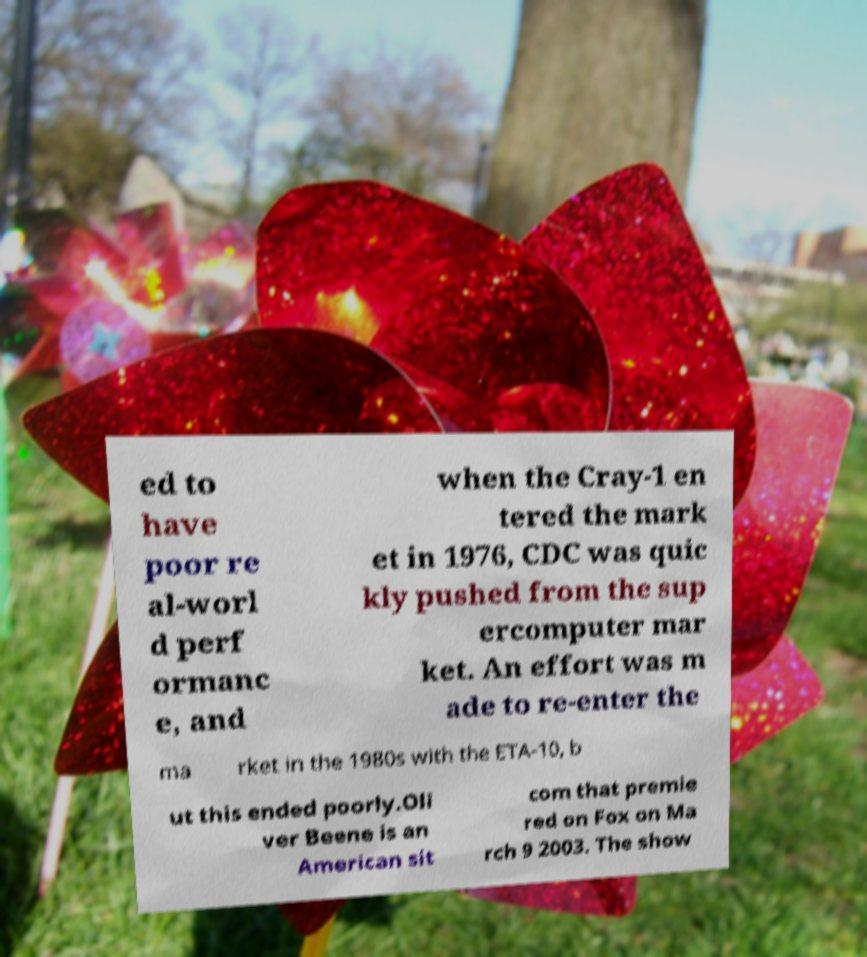Could you extract and type out the text from this image? ed to have poor re al-worl d perf ormanc e, and when the Cray-1 en tered the mark et in 1976, CDC was quic kly pushed from the sup ercomputer mar ket. An effort was m ade to re-enter the ma rket in the 1980s with the ETA-10, b ut this ended poorly.Oli ver Beene is an American sit com that premie red on Fox on Ma rch 9 2003. The show 